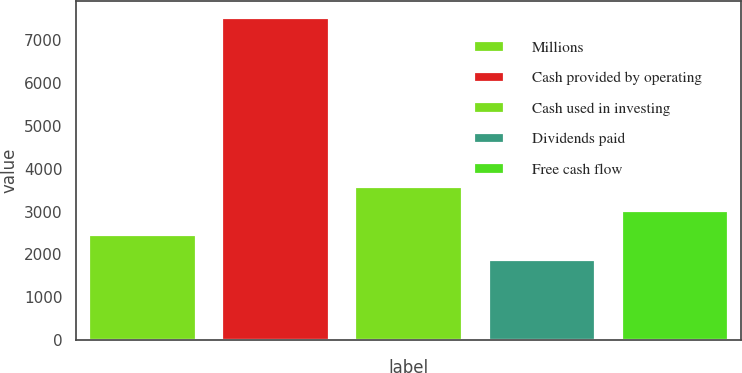<chart> <loc_0><loc_0><loc_500><loc_500><bar_chart><fcel>Millions<fcel>Cash provided by operating<fcel>Cash used in investing<fcel>Dividends paid<fcel>Free cash flow<nl><fcel>2443.6<fcel>7525<fcel>3572.8<fcel>1879<fcel>3008.2<nl></chart> 